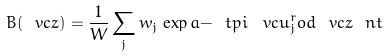Convert formula to latex. <formula><loc_0><loc_0><loc_500><loc_500>B ( \ v c z ) = \frac { 1 } { W } \sum _ { j } w _ { j } \, \exp a { - \ t p i \, \ v c u _ { j } ^ { r } o d \ v c z } \ n t</formula> 